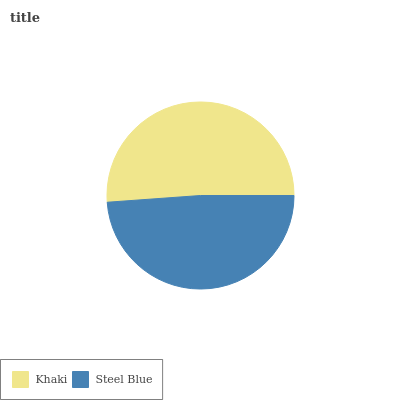Is Steel Blue the minimum?
Answer yes or no. Yes. Is Khaki the maximum?
Answer yes or no. Yes. Is Steel Blue the maximum?
Answer yes or no. No. Is Khaki greater than Steel Blue?
Answer yes or no. Yes. Is Steel Blue less than Khaki?
Answer yes or no. Yes. Is Steel Blue greater than Khaki?
Answer yes or no. No. Is Khaki less than Steel Blue?
Answer yes or no. No. Is Khaki the high median?
Answer yes or no. Yes. Is Steel Blue the low median?
Answer yes or no. Yes. Is Steel Blue the high median?
Answer yes or no. No. Is Khaki the low median?
Answer yes or no. No. 